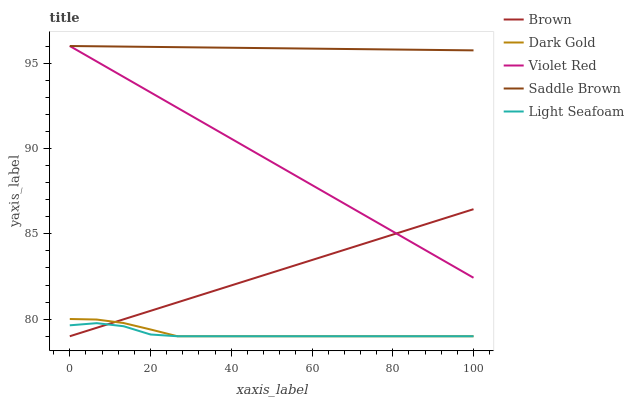Does Light Seafoam have the minimum area under the curve?
Answer yes or no. Yes. Does Saddle Brown have the maximum area under the curve?
Answer yes or no. Yes. Does Violet Red have the minimum area under the curve?
Answer yes or no. No. Does Violet Red have the maximum area under the curve?
Answer yes or no. No. Is Saddle Brown the smoothest?
Answer yes or no. Yes. Is Light Seafoam the roughest?
Answer yes or no. Yes. Is Violet Red the smoothest?
Answer yes or no. No. Is Violet Red the roughest?
Answer yes or no. No. Does Brown have the lowest value?
Answer yes or no. Yes. Does Violet Red have the lowest value?
Answer yes or no. No. Does Saddle Brown have the highest value?
Answer yes or no. Yes. Does Light Seafoam have the highest value?
Answer yes or no. No. Is Dark Gold less than Violet Red?
Answer yes or no. Yes. Is Violet Red greater than Dark Gold?
Answer yes or no. Yes. Does Brown intersect Violet Red?
Answer yes or no. Yes. Is Brown less than Violet Red?
Answer yes or no. No. Is Brown greater than Violet Red?
Answer yes or no. No. Does Dark Gold intersect Violet Red?
Answer yes or no. No. 